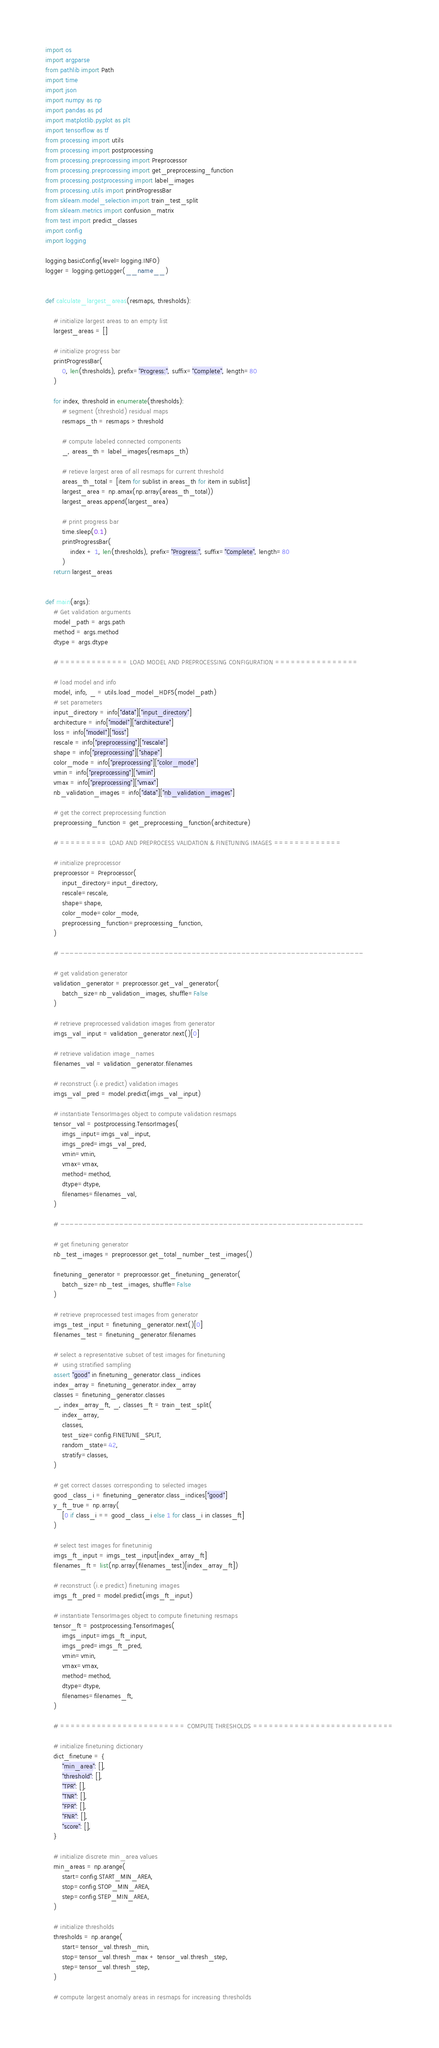Convert code to text. <code><loc_0><loc_0><loc_500><loc_500><_Python_>import os
import argparse
from pathlib import Path
import time
import json
import numpy as np
import pandas as pd
import matplotlib.pyplot as plt
import tensorflow as tf
from processing import utils
from processing import postprocessing
from processing.preprocessing import Preprocessor
from processing.preprocessing import get_preprocessing_function
from processing.postprocessing import label_images
from processing.utils import printProgressBar
from sklearn.model_selection import train_test_split
from sklearn.metrics import confusion_matrix
from test import predict_classes
import config
import logging

logging.basicConfig(level=logging.INFO)
logger = logging.getLogger(__name__)


def calculate_largest_areas(resmaps, thresholds):

    # initialize largest areas to an empty list
    largest_areas = []

    # initialize progress bar
    printProgressBar(
        0, len(thresholds), prefix="Progress:", suffix="Complete", length=80
    )

    for index, threshold in enumerate(thresholds):
        # segment (threshold) residual maps
        resmaps_th = resmaps > threshold

        # compute labeled connected components
        _, areas_th = label_images(resmaps_th)

        # retieve largest area of all resmaps for current threshold
        areas_th_total = [item for sublist in areas_th for item in sublist]
        largest_area = np.amax(np.array(areas_th_total))
        largest_areas.append(largest_area)

        # print progress bar
        time.sleep(0.1)
        printProgressBar(
            index + 1, len(thresholds), prefix="Progress:", suffix="Complete", length=80
        )
    return largest_areas


def main(args):
    # Get validation arguments
    model_path = args.path
    method = args.method
    dtype = args.dtype

    # ============= LOAD MODEL AND PREPROCESSING CONFIGURATION ================

    # load model and info
    model, info, _ = utils.load_model_HDF5(model_path)
    # set parameters
    input_directory = info["data"]["input_directory"]
    architecture = info["model"]["architecture"]
    loss = info["model"]["loss"]
    rescale = info["preprocessing"]["rescale"]
    shape = info["preprocessing"]["shape"]
    color_mode = info["preprocessing"]["color_mode"]
    vmin = info["preprocessing"]["vmin"]
    vmax = info["preprocessing"]["vmax"]
    nb_validation_images = info["data"]["nb_validation_images"]

    # get the correct preprocessing function
    preprocessing_function = get_preprocessing_function(architecture)

    # ========= LOAD AND PREPROCESS VALIDATION & FINETUNING IMAGES =============

    # initialize preprocessor
    preprocessor = Preprocessor(
        input_directory=input_directory,
        rescale=rescale,
        shape=shape,
        color_mode=color_mode,
        preprocessing_function=preprocessing_function,
    )

    # -------------------------------------------------------------------

    # get validation generator
    validation_generator = preprocessor.get_val_generator(
        batch_size=nb_validation_images, shuffle=False
    )

    # retrieve preprocessed validation images from generator
    imgs_val_input = validation_generator.next()[0]

    # retrieve validation image_names
    filenames_val = validation_generator.filenames

    # reconstruct (i.e predict) validation images
    imgs_val_pred = model.predict(imgs_val_input)

    # instantiate TensorImages object to compute validation resmaps
    tensor_val = postprocessing.TensorImages(
        imgs_input=imgs_val_input,
        imgs_pred=imgs_val_pred,
        vmin=vmin,
        vmax=vmax,
        method=method,
        dtype=dtype,
        filenames=filenames_val,
    )

    # -------------------------------------------------------------------

    # get finetuning generator
    nb_test_images = preprocessor.get_total_number_test_images()

    finetuning_generator = preprocessor.get_finetuning_generator(
        batch_size=nb_test_images, shuffle=False
    )

    # retrieve preprocessed test images from generator
    imgs_test_input = finetuning_generator.next()[0]
    filenames_test = finetuning_generator.filenames

    # select a representative subset of test images for finetuning
    #  using stratified sampling
    assert "good" in finetuning_generator.class_indices
    index_array = finetuning_generator.index_array
    classes = finetuning_generator.classes
    _, index_array_ft, _, classes_ft = train_test_split(
        index_array,
        classes,
        test_size=config.FINETUNE_SPLIT,
        random_state=42,
        stratify=classes,
    )

    # get correct classes corresponding to selected images
    good_class_i = finetuning_generator.class_indices["good"]
    y_ft_true = np.array(
        [0 if class_i == good_class_i else 1 for class_i in classes_ft]
    )

    # select test images for finetuninig
    imgs_ft_input = imgs_test_input[index_array_ft]
    filenames_ft = list(np.array(filenames_test)[index_array_ft])

    # reconstruct (i.e predict) finetuning images
    imgs_ft_pred = model.predict(imgs_ft_input)

    # instantiate TensorImages object to compute finetuning resmaps
    tensor_ft = postprocessing.TensorImages(
        imgs_input=imgs_ft_input,
        imgs_pred=imgs_ft_pred,
        vmin=vmin,
        vmax=vmax,
        method=method,
        dtype=dtype,
        filenames=filenames_ft,
    )

    # ======================== COMPUTE THRESHOLDS ===========================

    # initialize finetuning dictionary
    dict_finetune = {
        "min_area": [],
        "threshold": [],
        "TPR": [],
        "TNR": [],
        "FPR": [],
        "FNR": [],
        "score": [],
    }

    # initialize discrete min_area values
    min_areas = np.arange(
        start=config.START_MIN_AREA,
        stop=config.STOP_MIN_AREA,
        step=config.STEP_MIN_AREA,
    )

    # initialize thresholds
    thresholds = np.arange(
        start=tensor_val.thresh_min,
        stop=tensor_val.thresh_max + tensor_val.thresh_step,
        step=tensor_val.thresh_step,
    )

    # compute largest anomaly areas in resmaps for increasing thresholds</code> 